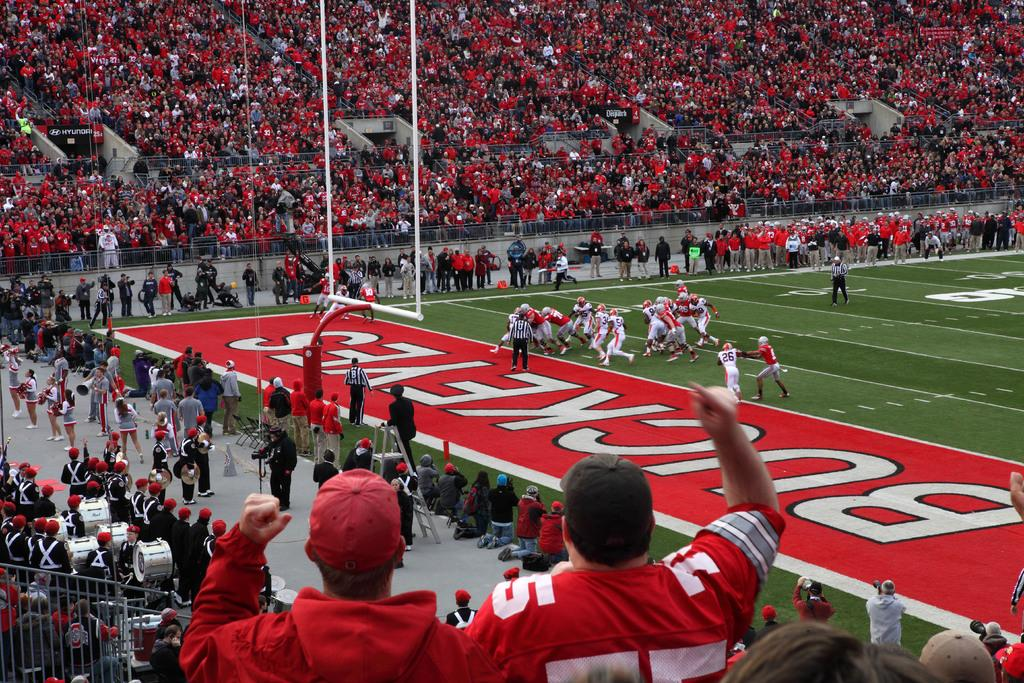<image>
Summarize the visual content of the image. A stadium full of fans watching the Buckeyes football team 